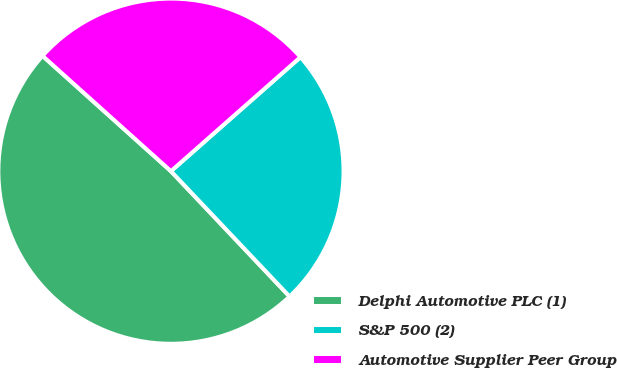Convert chart. <chart><loc_0><loc_0><loc_500><loc_500><pie_chart><fcel>Delphi Automotive PLC (1)<fcel>S&P 500 (2)<fcel>Automotive Supplier Peer Group<nl><fcel>48.71%<fcel>24.43%<fcel>26.86%<nl></chart> 